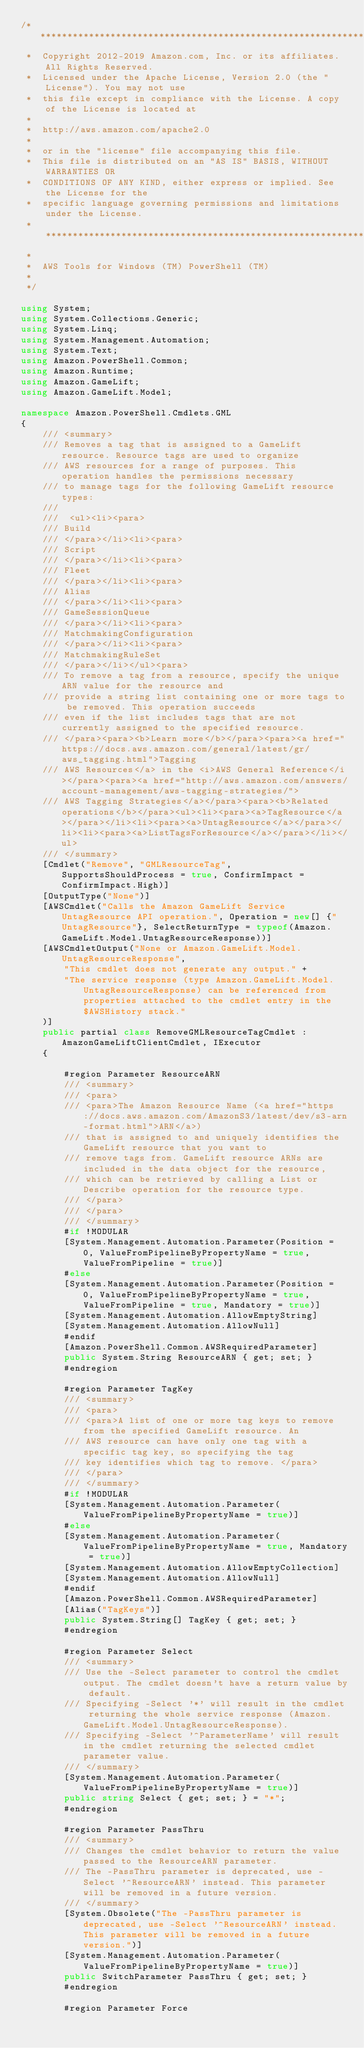Convert code to text. <code><loc_0><loc_0><loc_500><loc_500><_C#_>/*******************************************************************************
 *  Copyright 2012-2019 Amazon.com, Inc. or its affiliates. All Rights Reserved.
 *  Licensed under the Apache License, Version 2.0 (the "License"). You may not use
 *  this file except in compliance with the License. A copy of the License is located at
 *
 *  http://aws.amazon.com/apache2.0
 *
 *  or in the "license" file accompanying this file.
 *  This file is distributed on an "AS IS" BASIS, WITHOUT WARRANTIES OR
 *  CONDITIONS OF ANY KIND, either express or implied. See the License for the
 *  specific language governing permissions and limitations under the License.
 * *****************************************************************************
 *
 *  AWS Tools for Windows (TM) PowerShell (TM)
 *
 */

using System;
using System.Collections.Generic;
using System.Linq;
using System.Management.Automation;
using System.Text;
using Amazon.PowerShell.Common;
using Amazon.Runtime;
using Amazon.GameLift;
using Amazon.GameLift.Model;

namespace Amazon.PowerShell.Cmdlets.GML
{
    /// <summary>
    /// Removes a tag that is assigned to a GameLift resource. Resource tags are used to organize
    /// AWS resources for a range of purposes. This operation handles the permissions necessary
    /// to manage tags for the following GameLift resource types:
    /// 
    ///  <ul><li><para>
    /// Build
    /// </para></li><li><para>
    /// Script
    /// </para></li><li><para>
    /// Fleet
    /// </para></li><li><para>
    /// Alias
    /// </para></li><li><para>
    /// GameSessionQueue
    /// </para></li><li><para>
    /// MatchmakingConfiguration
    /// </para></li><li><para>
    /// MatchmakingRuleSet
    /// </para></li></ul><para>
    /// To remove a tag from a resource, specify the unique ARN value for the resource and
    /// provide a string list containing one or more tags to be removed. This operation succeeds
    /// even if the list includes tags that are not currently assigned to the specified resource.
    /// </para><para><b>Learn more</b></para><para><a href="https://docs.aws.amazon.com/general/latest/gr/aws_tagging.html">Tagging
    /// AWS Resources</a> in the <i>AWS General Reference</i></para><para><a href="http://aws.amazon.com/answers/account-management/aws-tagging-strategies/">
    /// AWS Tagging Strategies</a></para><para><b>Related operations</b></para><ul><li><para><a>TagResource</a></para></li><li><para><a>UntagResource</a></para></li><li><para><a>ListTagsForResource</a></para></li></ul>
    /// </summary>
    [Cmdlet("Remove", "GMLResourceTag", SupportsShouldProcess = true, ConfirmImpact = ConfirmImpact.High)]
    [OutputType("None")]
    [AWSCmdlet("Calls the Amazon GameLift Service UntagResource API operation.", Operation = new[] {"UntagResource"}, SelectReturnType = typeof(Amazon.GameLift.Model.UntagResourceResponse))]
    [AWSCmdletOutput("None or Amazon.GameLift.Model.UntagResourceResponse",
        "This cmdlet does not generate any output." +
        "The service response (type Amazon.GameLift.Model.UntagResourceResponse) can be referenced from properties attached to the cmdlet entry in the $AWSHistory stack."
    )]
    public partial class RemoveGMLResourceTagCmdlet : AmazonGameLiftClientCmdlet, IExecutor
    {
        
        #region Parameter ResourceARN
        /// <summary>
        /// <para>
        /// <para>The Amazon Resource Name (<a href="https://docs.aws.amazon.com/AmazonS3/latest/dev/s3-arn-format.html">ARN</a>)
        /// that is assigned to and uniquely identifies the GameLift resource that you want to
        /// remove tags from. GameLift resource ARNs are included in the data object for the resource,
        /// which can be retrieved by calling a List or Describe operation for the resource type.
        /// </para>
        /// </para>
        /// </summary>
        #if !MODULAR
        [System.Management.Automation.Parameter(Position = 0, ValueFromPipelineByPropertyName = true, ValueFromPipeline = true)]
        #else
        [System.Management.Automation.Parameter(Position = 0, ValueFromPipelineByPropertyName = true, ValueFromPipeline = true, Mandatory = true)]
        [System.Management.Automation.AllowEmptyString]
        [System.Management.Automation.AllowNull]
        #endif
        [Amazon.PowerShell.Common.AWSRequiredParameter]
        public System.String ResourceARN { get; set; }
        #endregion
        
        #region Parameter TagKey
        /// <summary>
        /// <para>
        /// <para>A list of one or more tag keys to remove from the specified GameLift resource. An
        /// AWS resource can have only one tag with a specific tag key, so specifying the tag
        /// key identifies which tag to remove. </para>
        /// </para>
        /// </summary>
        #if !MODULAR
        [System.Management.Automation.Parameter(ValueFromPipelineByPropertyName = true)]
        #else
        [System.Management.Automation.Parameter(ValueFromPipelineByPropertyName = true, Mandatory = true)]
        [System.Management.Automation.AllowEmptyCollection]
        [System.Management.Automation.AllowNull]
        #endif
        [Amazon.PowerShell.Common.AWSRequiredParameter]
        [Alias("TagKeys")]
        public System.String[] TagKey { get; set; }
        #endregion
        
        #region Parameter Select
        /// <summary>
        /// Use the -Select parameter to control the cmdlet output. The cmdlet doesn't have a return value by default.
        /// Specifying -Select '*' will result in the cmdlet returning the whole service response (Amazon.GameLift.Model.UntagResourceResponse).
        /// Specifying -Select '^ParameterName' will result in the cmdlet returning the selected cmdlet parameter value.
        /// </summary>
        [System.Management.Automation.Parameter(ValueFromPipelineByPropertyName = true)]
        public string Select { get; set; } = "*";
        #endregion
        
        #region Parameter PassThru
        /// <summary>
        /// Changes the cmdlet behavior to return the value passed to the ResourceARN parameter.
        /// The -PassThru parameter is deprecated, use -Select '^ResourceARN' instead. This parameter will be removed in a future version.
        /// </summary>
        [System.Obsolete("The -PassThru parameter is deprecated, use -Select '^ResourceARN' instead. This parameter will be removed in a future version.")]
        [System.Management.Automation.Parameter(ValueFromPipelineByPropertyName = true)]
        public SwitchParameter PassThru { get; set; }
        #endregion
        
        #region Parameter Force</code> 